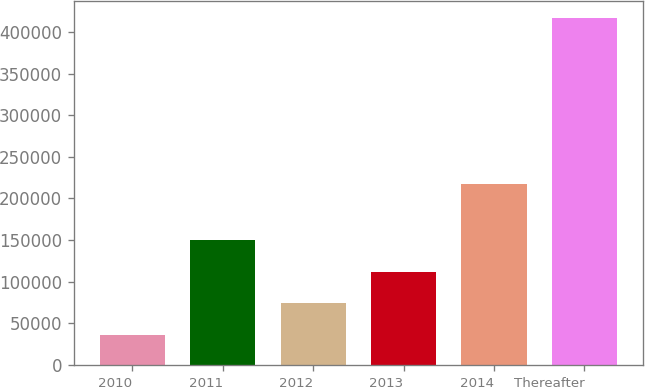<chart> <loc_0><loc_0><loc_500><loc_500><bar_chart><fcel>2010<fcel>2011<fcel>2012<fcel>2013<fcel>2014<fcel>Thereafter<nl><fcel>35982<fcel>150212<fcel>74058.6<fcel>112135<fcel>216952<fcel>416748<nl></chart> 